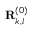<formula> <loc_0><loc_0><loc_500><loc_500>R _ { k , l } ^ { ( 0 ) }</formula> 